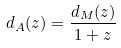Convert formula to latex. <formula><loc_0><loc_0><loc_500><loc_500>d _ { A } ( z ) = \frac { d _ { M } ( z ) } { 1 + z }</formula> 